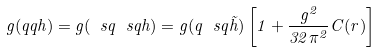Convert formula to latex. <formula><loc_0><loc_0><loc_500><loc_500>g ( q q h ) = g ( \ s q \ s q h ) = g ( q \ s q \tilde { h } ) \left [ 1 + \frac { g ^ { 2 } } { 3 2 \pi ^ { 2 } } C ( r ) \right ]</formula> 